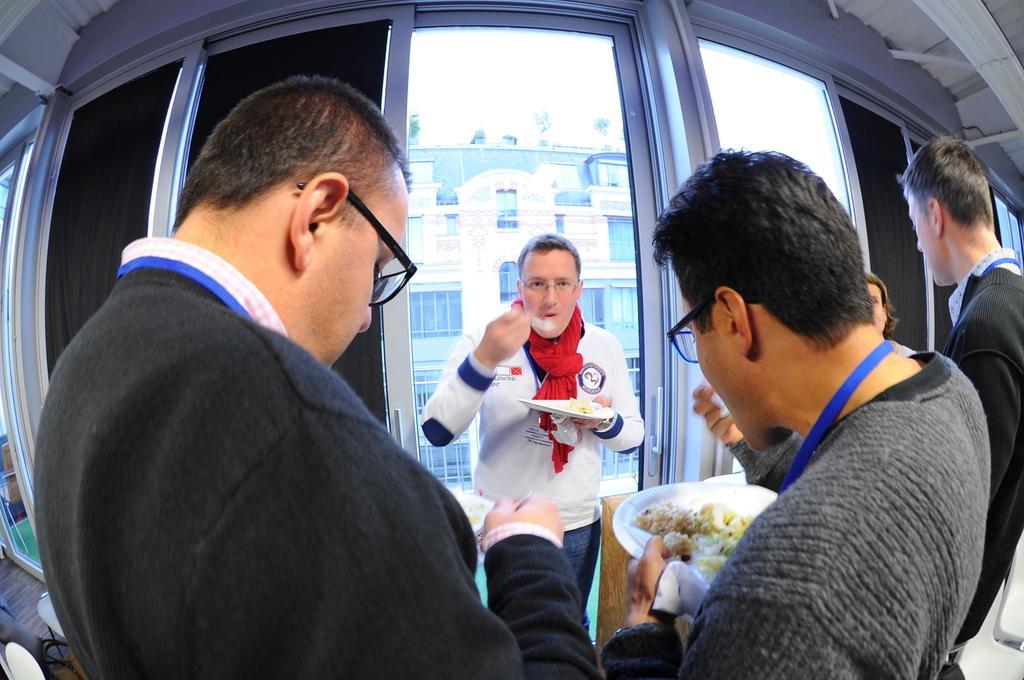In one or two sentences, can you explain what this image depicts? In the foreground of the picture we can see group of people, they are holding plates and eating food. In the middle of the picture we can see window blinds, windows and door. In the background we can see building and sky. 